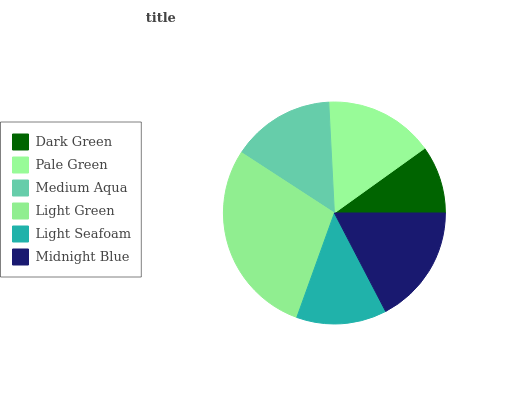Is Dark Green the minimum?
Answer yes or no. Yes. Is Light Green the maximum?
Answer yes or no. Yes. Is Pale Green the minimum?
Answer yes or no. No. Is Pale Green the maximum?
Answer yes or no. No. Is Pale Green greater than Dark Green?
Answer yes or no. Yes. Is Dark Green less than Pale Green?
Answer yes or no. Yes. Is Dark Green greater than Pale Green?
Answer yes or no. No. Is Pale Green less than Dark Green?
Answer yes or no. No. Is Pale Green the high median?
Answer yes or no. Yes. Is Medium Aqua the low median?
Answer yes or no. Yes. Is Midnight Blue the high median?
Answer yes or no. No. Is Pale Green the low median?
Answer yes or no. No. 